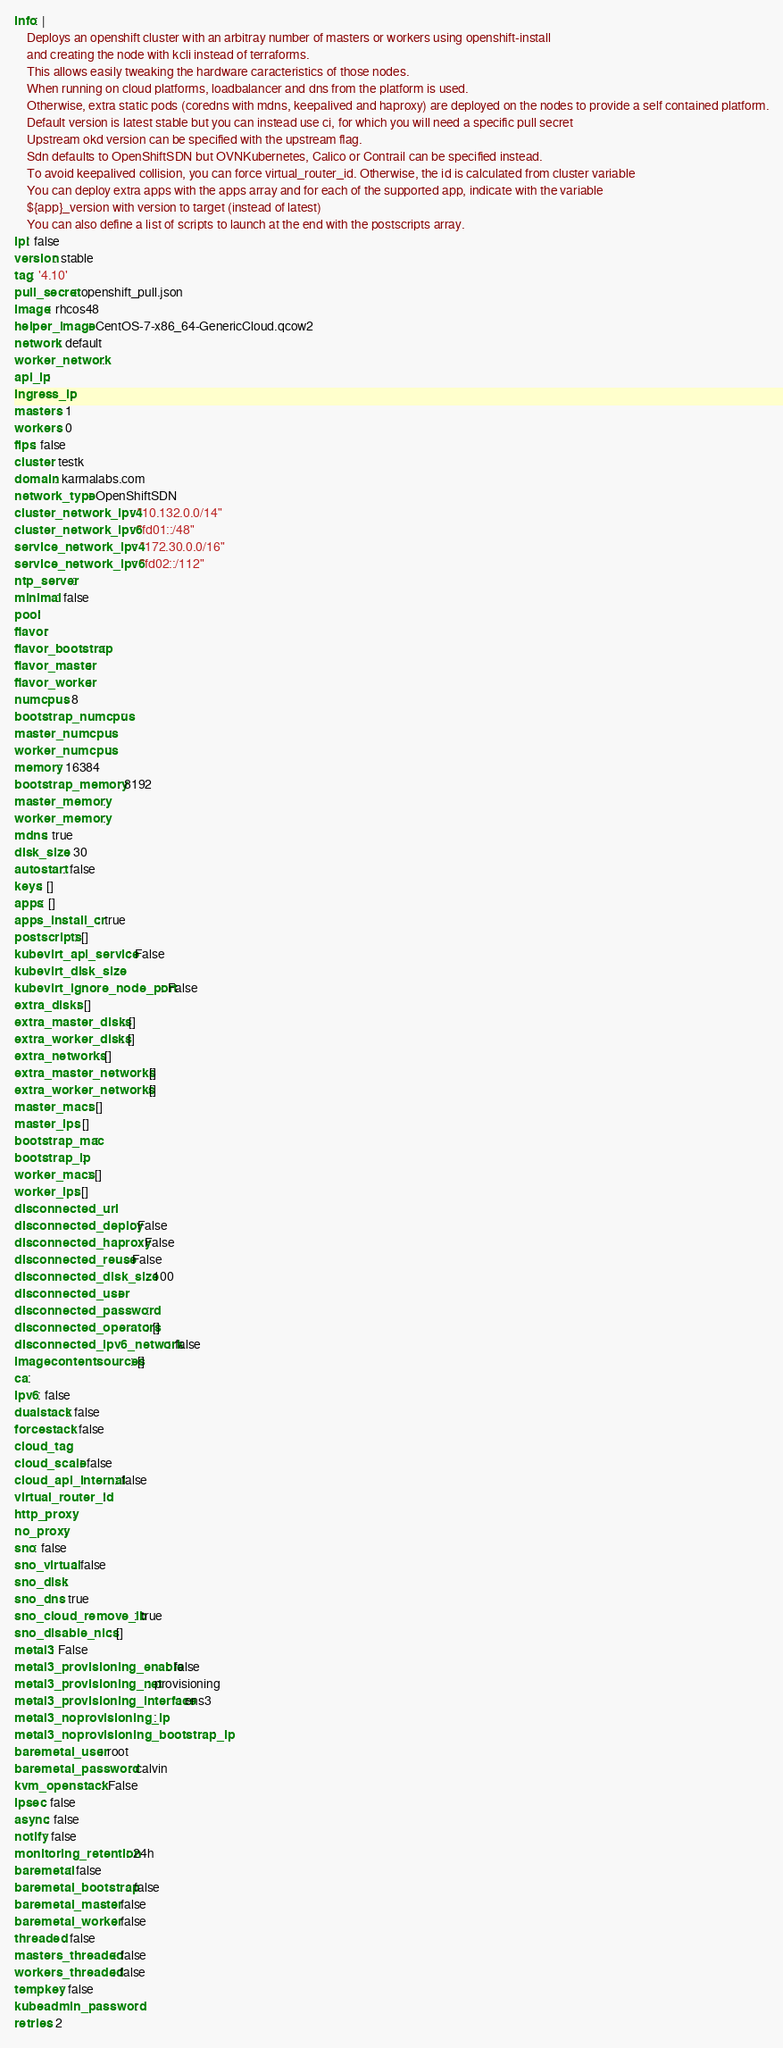Convert code to text. <code><loc_0><loc_0><loc_500><loc_500><_YAML_>info: |
    Deploys an openshift cluster with an arbitray number of masters or workers using openshift-install
    and creating the node with kcli instead of terraforms.
    This allows easily tweaking the hardware caracteristics of those nodes.
    When running on cloud platforms, loadbalancer and dns from the platform is used.
    Otherwise, extra static pods (coredns with mdns, keepalived and haproxy) are deployed on the nodes to provide a self contained platform.
    Default version is latest stable but you can instead use ci, for which you will need a specific pull secret
    Upstream okd version can be specified with the upstream flag.
    Sdn defaults to OpenShiftSDN but OVNKubernetes, Calico or Contrail can be specified instead.
    To avoid keepalived collision, you can force virtual_router_id. Otherwise, the id is calculated from cluster variable
    You can deploy extra apps with the apps array and for each of the supported app, indicate with the variable
    ${app}_version with version to target (instead of latest)
    You can also define a list of scripts to launch at the end with the postscripts array.
ipi: false
version: stable
tag: '4.10'
pull_secret: openshift_pull.json
image: rhcos48
helper_image: CentOS-7-x86_64-GenericCloud.qcow2
network: default
worker_network:
api_ip: 
ingress_ip: 
masters: 1
workers: 0
fips: false
cluster: testk
domain: karmalabs.com
network_type: OpenShiftSDN
cluster_network_ipv4: "10.132.0.0/14"
cluster_network_ipv6: "fd01::/48"
service_network_ipv4: "172.30.0.0/16"
service_network_ipv6: "fd02::/112"
ntp_server:
minimal: false
pool:
flavor:
flavor_bootstrap:
flavor_master:
flavor_worker:
numcpus: 8
bootstrap_numcpus:
master_numcpus:
worker_numcpus:
memory: 16384
bootstrap_memory: 8192
master_memory:
worker_memory:
mdns: true
disk_size: 30
autostart: false
keys: []
apps: []
apps_install_cr: true
postscripts: []
kubevirt_api_service: False
kubevirt_disk_size:
kubevirt_ignore_node_port: False
extra_disks: []
extra_master_disks: []
extra_worker_disks: []
extra_networks: []
extra_master_networks: []
extra_worker_networks: []
master_macs: []
master_ips: []
bootstrap_mac: 
bootstrap_ip: 
worker_macs: []
worker_ips: []
disconnected_url:
disconnected_deploy: False
disconnected_haproxy: False
disconnected_reuse: False
disconnected_disk_size: 100
disconnected_user:
disconnected_password:
disconnected_operators: []
disconnected_ipv6_network: false
imagecontentsources: []
ca:
ipv6: false
dualstack: false
forcestack: false
cloud_tag:
cloud_scale: false
cloud_api_internal: false
virtual_router_id:
http_proxy:
no_proxy:
sno: false
sno_virtual: false
sno_disk:
sno_dns: true
sno_cloud_remove_lb: true
sno_disable_nics: []
metal3: False
metal3_provisioning_enable: false
metal3_provisioning_net: provisioning
metal3_provisioning_interface: ens3
metal3_noprovisioning_ip:
metal3_noprovisioning_bootstrap_ip:
baremetal_user: root
baremetal_password: calvin
kvm_openstack: False
ipsec: false
async: false
notify: false
monitoring_retention: 24h
baremetal: false
baremetal_bootstrap: false
baremetal_master: false
baremetal_worker: false
threaded: false
masters_threaded: false
workers_threaded: false
tempkey: false
kubeadmin_password:
retries: 2
</code> 